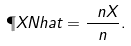<formula> <loc_0><loc_0><loc_500><loc_500>\P X N h a t = \frac { \ n X } { n } .</formula> 